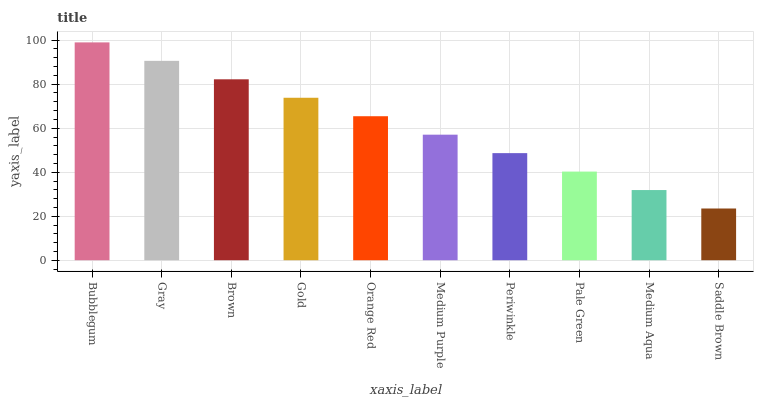Is Saddle Brown the minimum?
Answer yes or no. Yes. Is Bubblegum the maximum?
Answer yes or no. Yes. Is Gray the minimum?
Answer yes or no. No. Is Gray the maximum?
Answer yes or no. No. Is Bubblegum greater than Gray?
Answer yes or no. Yes. Is Gray less than Bubblegum?
Answer yes or no. Yes. Is Gray greater than Bubblegum?
Answer yes or no. No. Is Bubblegum less than Gray?
Answer yes or no. No. Is Orange Red the high median?
Answer yes or no. Yes. Is Medium Purple the low median?
Answer yes or no. Yes. Is Medium Purple the high median?
Answer yes or no. No. Is Gold the low median?
Answer yes or no. No. 